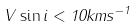Convert formula to latex. <formula><loc_0><loc_0><loc_500><loc_500>V \sin i < 1 0 k m s ^ { - 1 }</formula> 